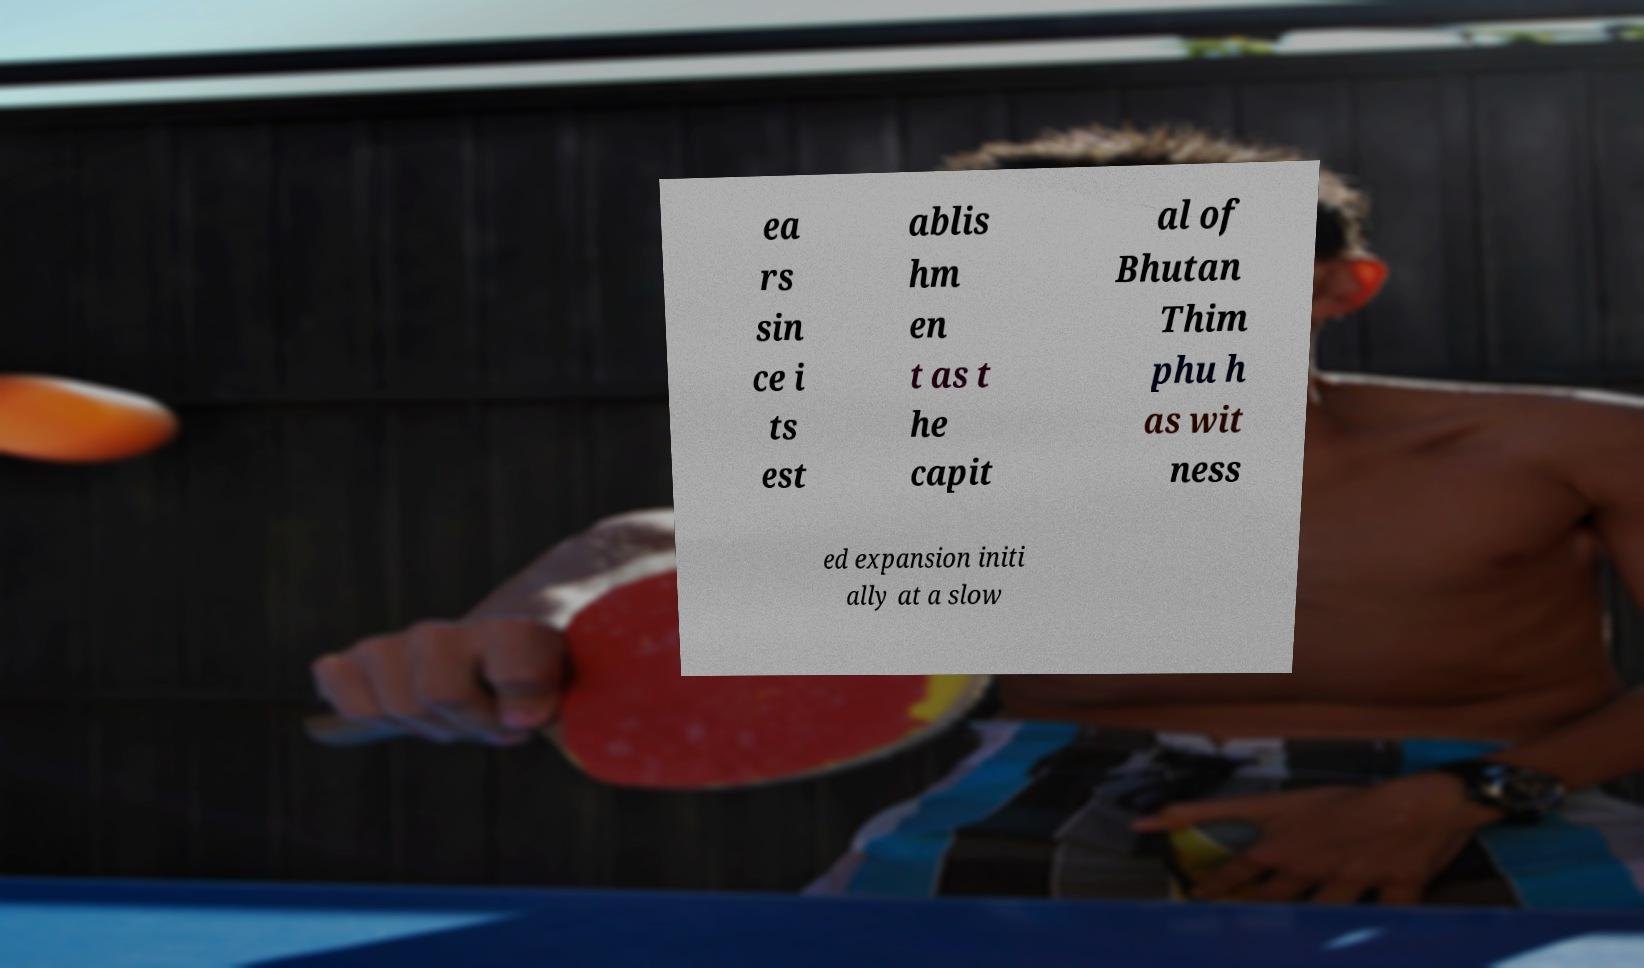Can you read and provide the text displayed in the image?This photo seems to have some interesting text. Can you extract and type it out for me? ea rs sin ce i ts est ablis hm en t as t he capit al of Bhutan Thim phu h as wit ness ed expansion initi ally at a slow 